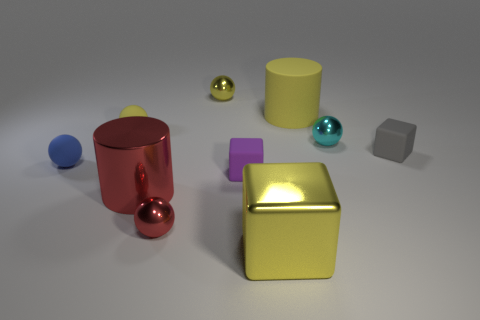Subtract all red metal balls. How many balls are left? 4 Subtract all red cylinders. How many cylinders are left? 1 Subtract all gray cylinders. Subtract all green blocks. How many cylinders are left? 2 Subtract all green blocks. How many blue cylinders are left? 0 Subtract all tiny red cylinders. Subtract all cyan shiny spheres. How many objects are left? 9 Add 7 small gray rubber objects. How many small gray rubber objects are left? 8 Add 9 purple blocks. How many purple blocks exist? 10 Subtract 0 brown blocks. How many objects are left? 10 Subtract all blocks. How many objects are left? 7 Subtract 1 cylinders. How many cylinders are left? 1 